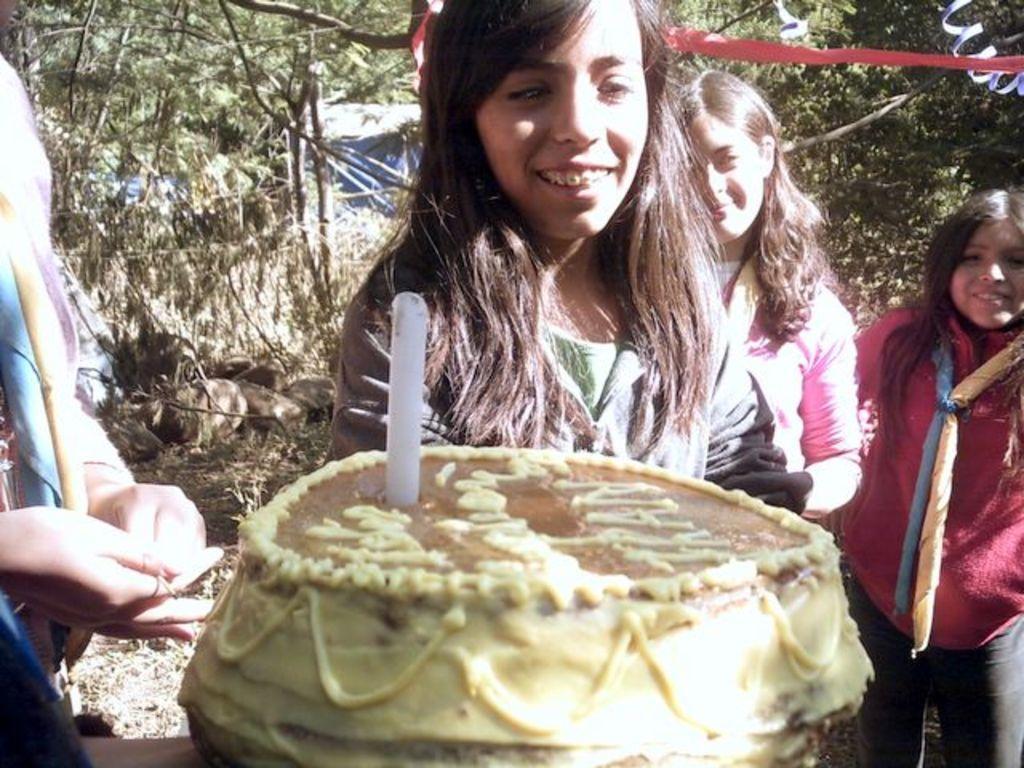Describe this image in one or two sentences. In this image I can see few women and I can see smile on their faces. Here I can see yellow and brown colour cake. I can also see white colour thing over here and in background I can see number of trees. 